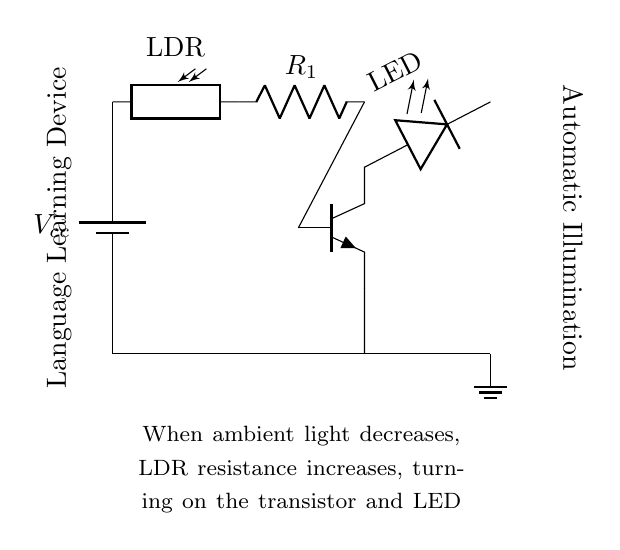What type of sensor is used in this circuit? The circuit uses a photoresistor, which changes its resistance based on the ambient light levels.
Answer: photoresistor What component controls the LED illumination? The transistor regulates the LED based on the signal received from the photoresistor. When the light levels drop, the transistor turns on, allowing current to flow to the LED.
Answer: transistor What happens to the resistance of the photoresistor in low light? The resistance of the photoresistor increases when the ambient light decreases, which is the principle behind its operation in this circuit.
Answer: increases What is the role of resistor R1 in the circuit? Resistor R1 is used to limit the current flowing through the photoresistor and the base of the transistor, ensuring safe operation of these components.
Answer: current limiting How does the circuit respond when the light level decreases? When light levels decrease, the resistance of the photoresistor increases, allowing more current to flow through the transistor and turning on the LED, illuminating the device.
Answer: LED turns on What is the voltage label for the power supply in this circuit? The voltage label for the power supply is Vcc, which indicates the supply voltage for the circuit components.
Answer: Vcc What type of connection is between the transistor collector and the LED? The transistor collector is connected to the anode of the LED, allowing current to flow through the LED when the transistor is turned on.
Answer: collector to LED anode 